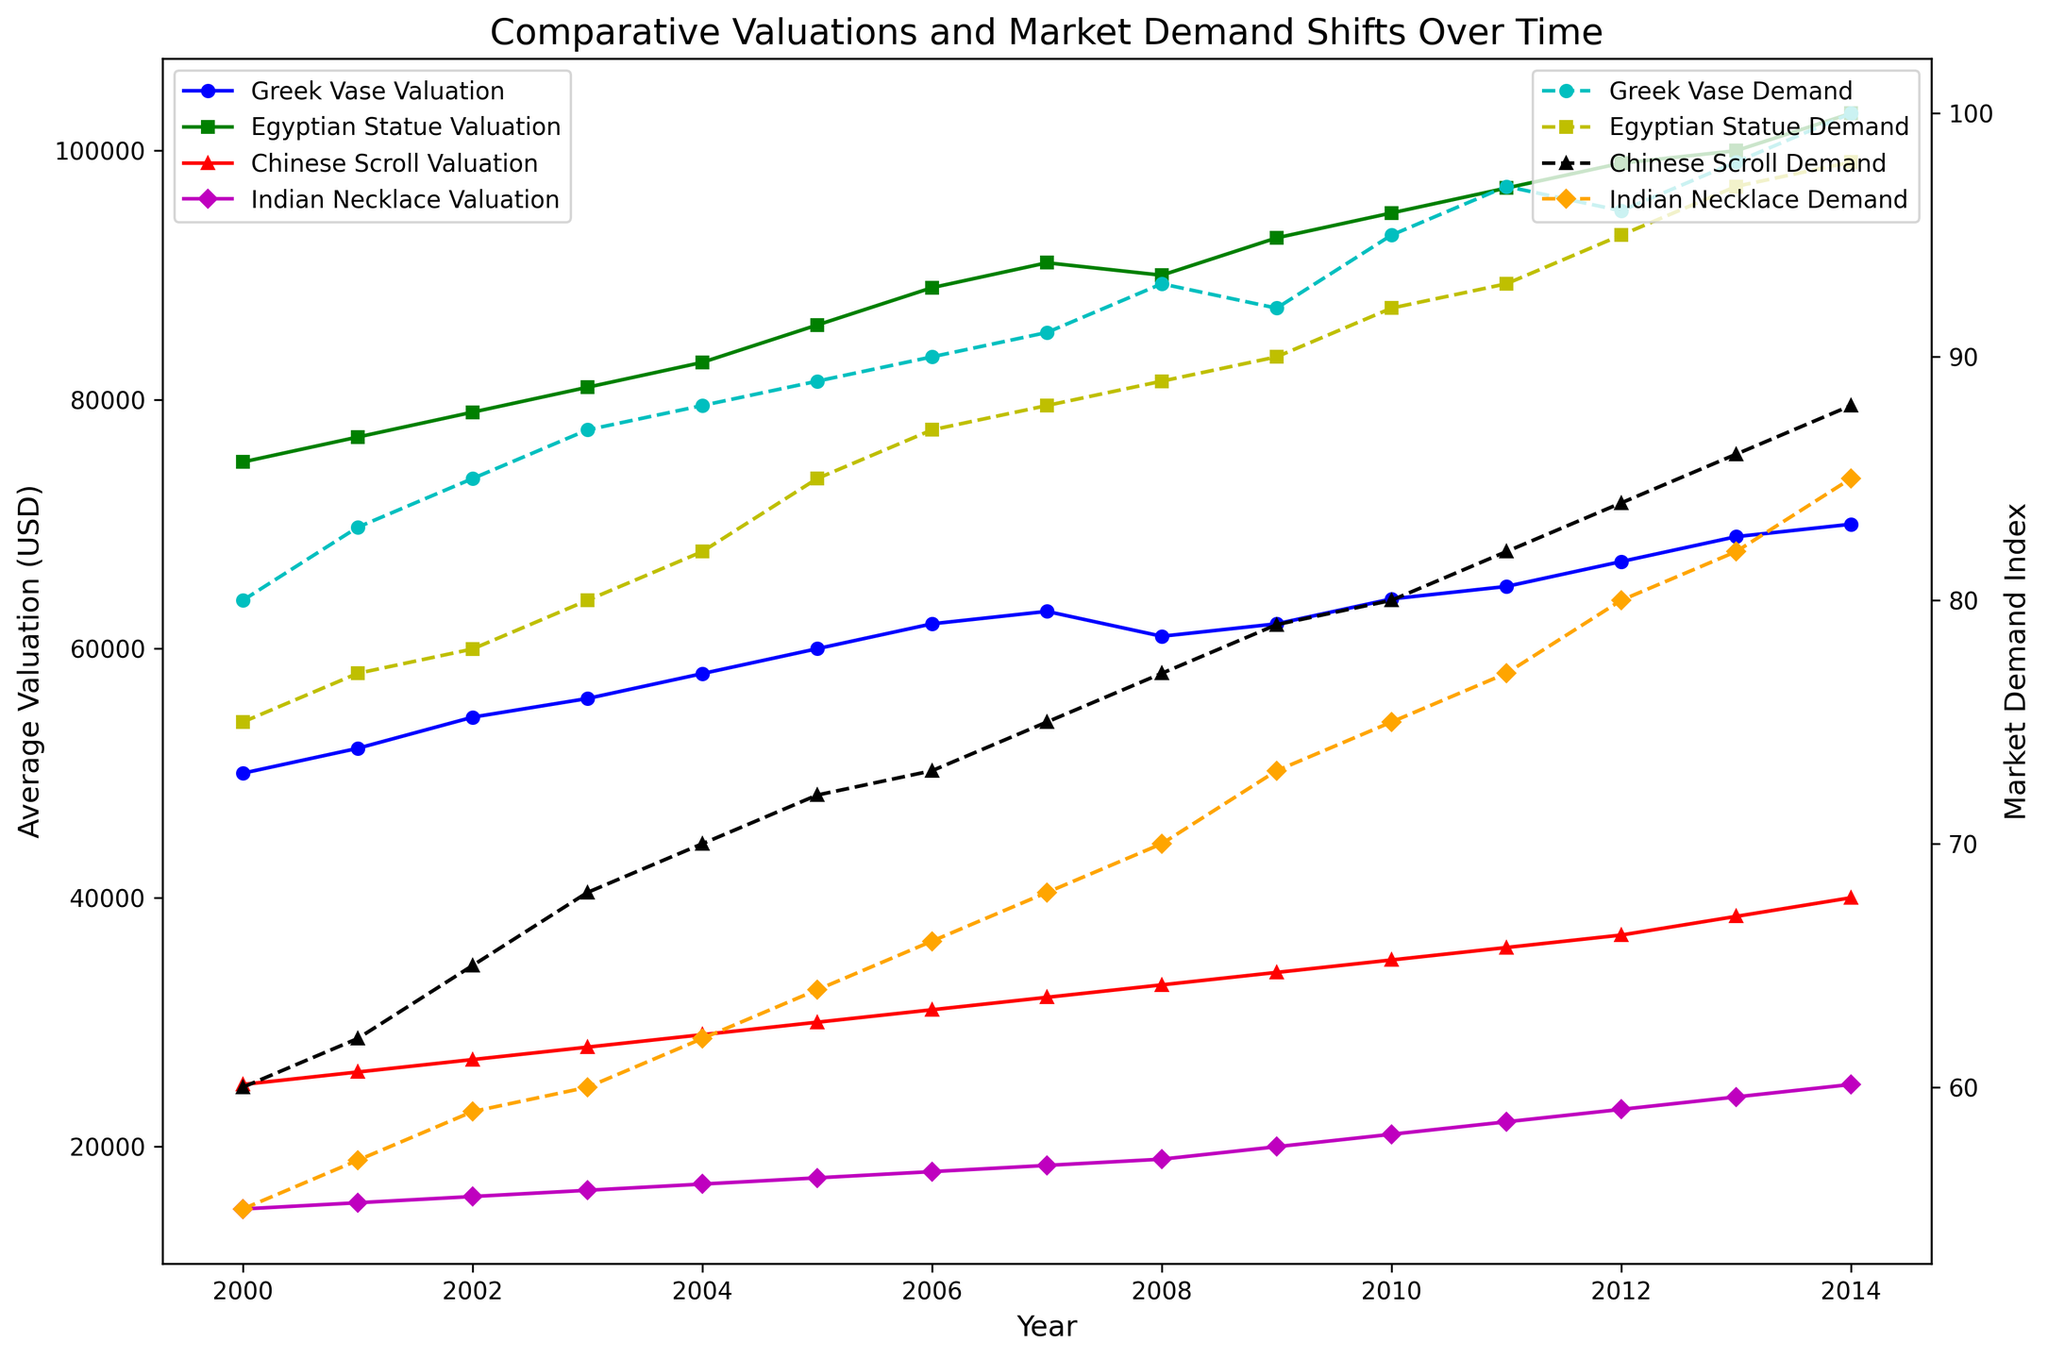What's the overall trend in the valuation of Greek vases over the years 2000 to 2014? To observe the trend in the valuation, we examine the slope of the line for Greek vases in the primary axis (solid line, blue). From 2000 to 2014, the line consistently goes upwards, indicating a positive or increasing trend.
Answer: Increasing How does the market demand index for Egyptian statues in 2014 compare to its average market demand index from 2000 to 2014? To find the answer, first note the market demand index for Egyptian statues in 2014, which is 98 (right axis, dashed yellow line). The average market demand index for Egyptian statues from 2000 to 2014 is found by averaging the index values over these years: (75+77+78+80+82+85+87+88+89+90+92+93+95+97+98)/15 ≈ 86.5. Comparing 98 with 86.5 shows that it is higher.
Answer: Higher Between which years did the Chinese scrolls experience the most significant increase in average valuation? To find the most significant increase, examine the primary axis (solid red line) for Chinese scrolls. The sloped line is steepest between 2012 and 2013, where the average valuation rises from 37000 to 38500, an increase of 1500. Other years show smaller increases.
Answer: 2012 to 2013 Which artifact showed the highest market demand in 2014? To find the highest market demand in 2014, we compare the end points of the dashed lines on the secondary axis. The Indian necklace has the highest market demand index in 2014, represented by the dashed orange line at 85.
Answer: Indian necklace Did any artifact's valuation decrease during a specific year interval, and if so, which? Looking at the primary axis lines: the Greek vase (blue solid line) experienced a decrease between 2007 and 2008, where the average valuation drops from 63000 to 61000. Other artifacts consistently increase in value.
Answer: Greek vase Which artifact type had the most stable market demand index from 2000 to 2014? To determine stability, observe the variability or fluctuations in the secondary axis lines. The Indian necklace (dashed orange line) has the least fluctuation in the market demand index, showing a steady climb without sharp changes.
Answer: Indian necklace Comparing the valuation trends, which artifact type showed the highest overall increase from 2000 to 2014? To determine the overall increase, we find the difference between the values in 2014 and 2000 for each artifact:
Greek vase: 70000 - 50000 = 20000
Egyptian statue: 103000 - 75000 = 28000
Chinese scroll: 40000 - 25000 = 15000
Indian necklace: 25000 - 15000 = 10000
The Egyptian statue shows the highest overall increase of 28000.
Answer: Egyptian statue How do the market demand trends for Greek vases and Indian necklaces compare from 2000 to 2014? To compare, examine the dashed lines for Greek vases (cyan) and Indian necklaces (orange). Both show an increasing trend, but the Greek vase has higher absolute values and a steeper increase overall. The Indian necklace increases steadily but more smoothly and with less variability.
Answer: Greek vases increase more steeply Which artifact had the highest average valuation in 2005? To find this, check the primary axis for valuations in 2005. The average valuation for the Egyptian statue (green solid line) is higher than the others, with 86000.
Answer: Egyptian statue 